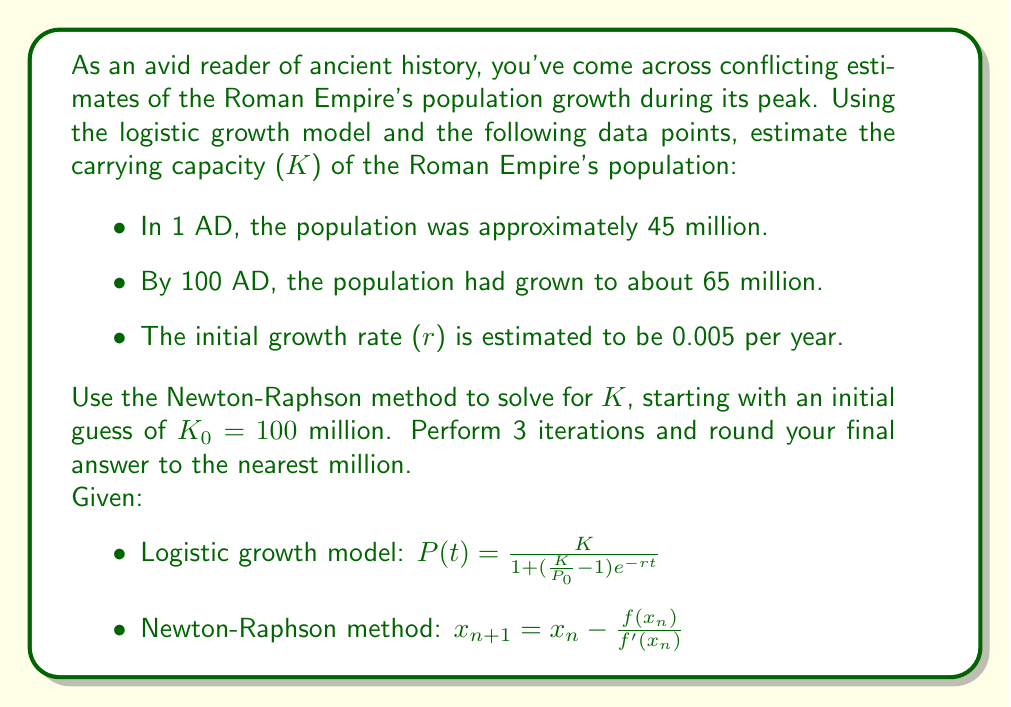Give your solution to this math problem. To solve this problem, we'll use the Newton-Raphson method to find the carrying capacity (K) that satisfies the logistic growth model for the given data points. Let's break it down step by step:

1) First, we need to set up our equation using the logistic growth model:

   $65 = \frac{K}{1 + (\frac{K}{45} - 1)e^{-0.005 \cdot 100}}$

2) Let's define a function f(K) that equals zero when K is the correct carrying capacity:

   $f(K) = \frac{K}{1 + (\frac{K}{45} - 1)e^{-0.5}} - 65 = 0$

3) To use the Newton-Raphson method, we also need the derivative of f(K):

   $f'(K) = \frac{1 + (\frac{K}{45} - 1)e^{-0.5} - \frac{K}{45}e^{-0.5}}{(1 + (\frac{K}{45} - 1)e^{-0.5})^2}$

4) Now we can apply the Newton-Raphson method:

   $K_{n+1} = K_n - \frac{f(K_n)}{f'(K_n)}$

5) Let's perform 3 iterations:

   Iteration 1:
   $K_1 = 100 - \frac{f(100)}{f'(100)} \approx 86.7759$

   Iteration 2:
   $K_2 = 86.7759 - \frac{f(86.7759)}{f'(86.7759)} \approx 85.4487$

   Iteration 3:
   $K_3 = 85.4487 - \frac{f(85.4487)}{f'(85.4487)} \approx 85.4038$

6) Rounding to the nearest million, we get our final answer.
Answer: The estimated carrying capacity (K) of the Roman Empire's population is 85 million. 